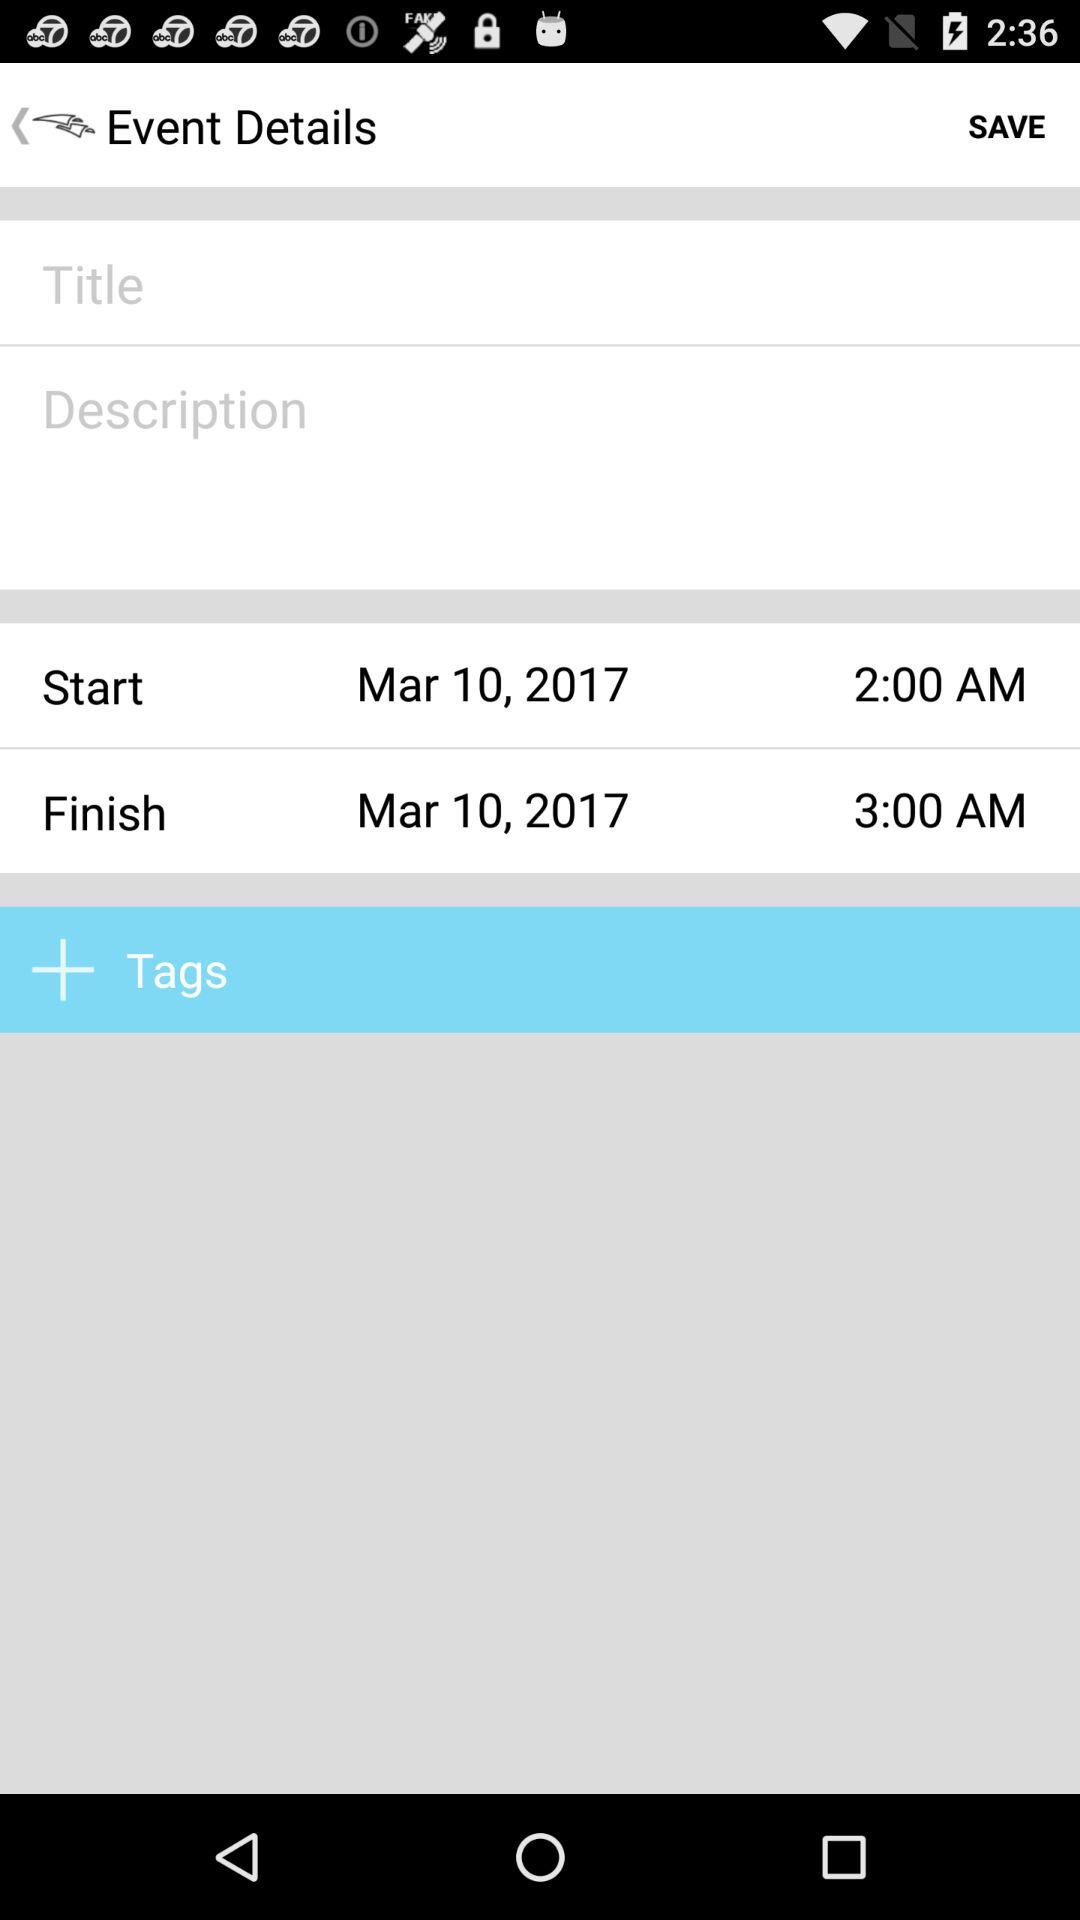When were the event details saved?
When the provided information is insufficient, respond with <no answer>. <no answer> 